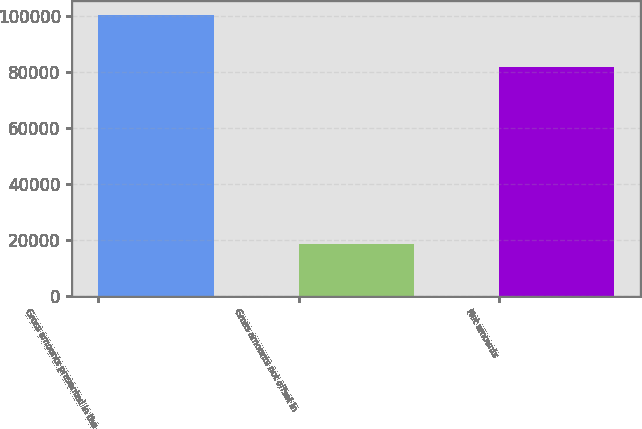Convert chart to OTSL. <chart><loc_0><loc_0><loc_500><loc_500><bar_chart><fcel>Gross amounts presented in the<fcel>Gross amounts not offset in<fcel>Net amounts<nl><fcel>100038<fcel>18313<fcel>81725<nl></chart> 